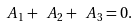<formula> <loc_0><loc_0><loc_500><loc_500>\ A _ { 1 } + \ A _ { 2 } + \ A _ { 3 } = 0 .</formula> 